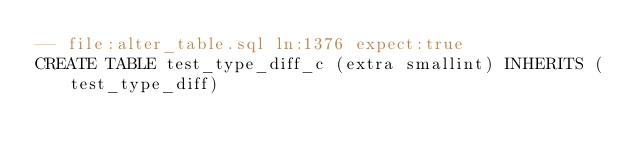<code> <loc_0><loc_0><loc_500><loc_500><_SQL_>-- file:alter_table.sql ln:1376 expect:true
CREATE TABLE test_type_diff_c (extra smallint) INHERITS (test_type_diff)
</code> 